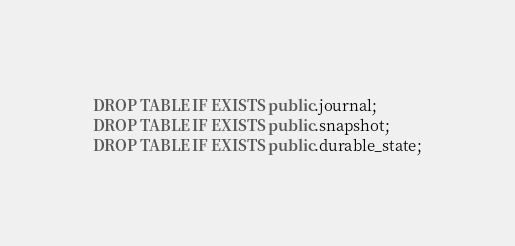<code> <loc_0><loc_0><loc_500><loc_500><_SQL_>DROP TABLE IF EXISTS public.journal;
DROP TABLE IF EXISTS public.snapshot;
DROP TABLE IF EXISTS public.durable_state;
</code> 